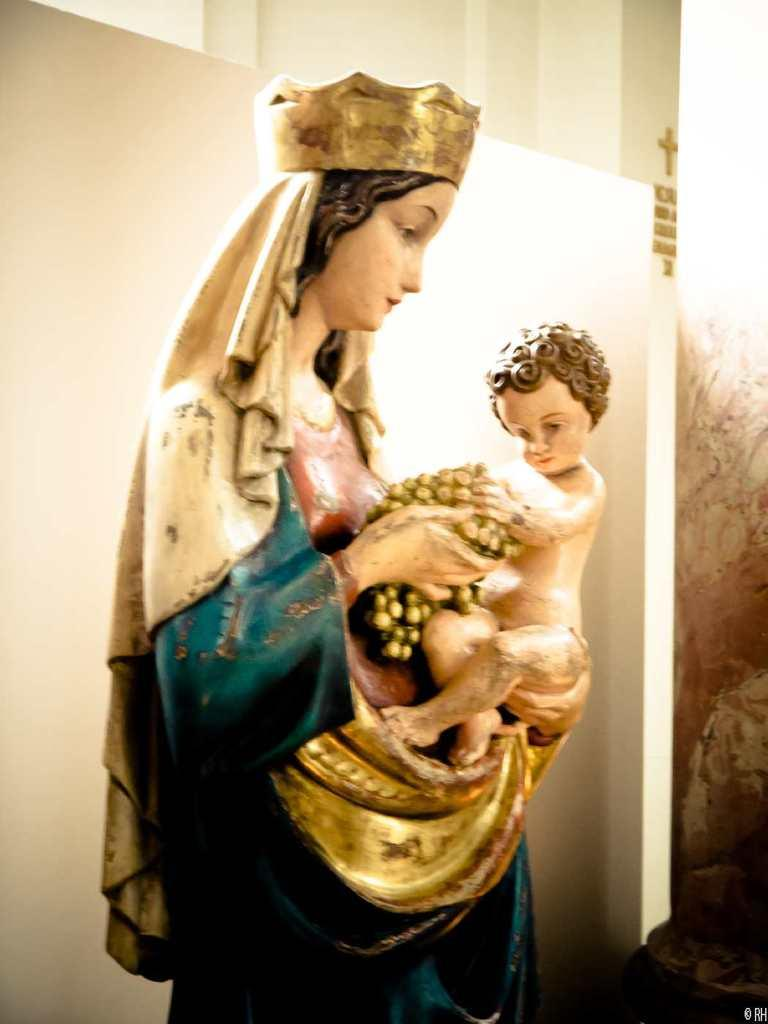What is the main subject of the image? There is a statue of a woman in the image. What is the woman holding in her hands? The woman is holding a kid in her hands. What else is the woman holding in her hands? The woman is also holding an object in her hands. What can be seen in the background of the image? There is a wall and other objects in the background of the image. What type of pump can be seen in the woman's hand in the image? There is no pump present in the woman's hand or in the image. 